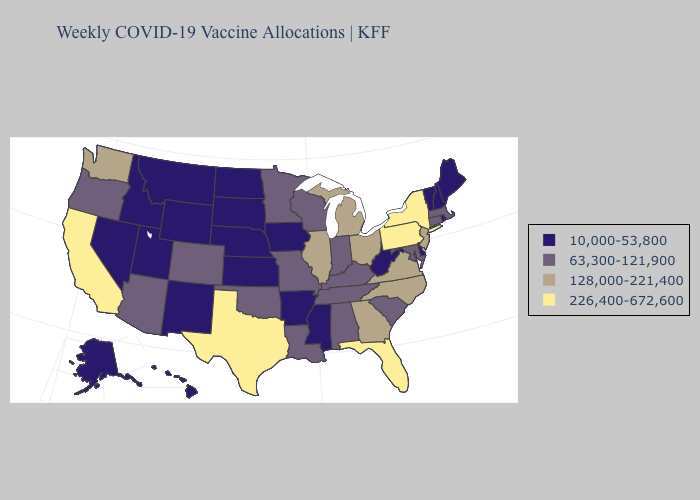Name the states that have a value in the range 63,300-121,900?
Concise answer only. Alabama, Arizona, Colorado, Connecticut, Indiana, Kentucky, Louisiana, Maryland, Massachusetts, Minnesota, Missouri, Oklahoma, Oregon, South Carolina, Tennessee, Wisconsin. Does Utah have the lowest value in the USA?
Be succinct. Yes. Among the states that border Indiana , does Illinois have the lowest value?
Keep it brief. No. What is the lowest value in the West?
Short answer required. 10,000-53,800. What is the highest value in the South ?
Keep it brief. 226,400-672,600. Name the states that have a value in the range 10,000-53,800?
Keep it brief. Alaska, Arkansas, Delaware, Hawaii, Idaho, Iowa, Kansas, Maine, Mississippi, Montana, Nebraska, Nevada, New Hampshire, New Mexico, North Dakota, Rhode Island, South Dakota, Utah, Vermont, West Virginia, Wyoming. Name the states that have a value in the range 63,300-121,900?
Keep it brief. Alabama, Arizona, Colorado, Connecticut, Indiana, Kentucky, Louisiana, Maryland, Massachusetts, Minnesota, Missouri, Oklahoma, Oregon, South Carolina, Tennessee, Wisconsin. Name the states that have a value in the range 63,300-121,900?
Be succinct. Alabama, Arizona, Colorado, Connecticut, Indiana, Kentucky, Louisiana, Maryland, Massachusetts, Minnesota, Missouri, Oklahoma, Oregon, South Carolina, Tennessee, Wisconsin. Name the states that have a value in the range 128,000-221,400?
Answer briefly. Georgia, Illinois, Michigan, New Jersey, North Carolina, Ohio, Virginia, Washington. Name the states that have a value in the range 63,300-121,900?
Be succinct. Alabama, Arizona, Colorado, Connecticut, Indiana, Kentucky, Louisiana, Maryland, Massachusetts, Minnesota, Missouri, Oklahoma, Oregon, South Carolina, Tennessee, Wisconsin. Does the first symbol in the legend represent the smallest category?
Keep it brief. Yes. Name the states that have a value in the range 63,300-121,900?
Short answer required. Alabama, Arizona, Colorado, Connecticut, Indiana, Kentucky, Louisiana, Maryland, Massachusetts, Minnesota, Missouri, Oklahoma, Oregon, South Carolina, Tennessee, Wisconsin. Name the states that have a value in the range 226,400-672,600?
Keep it brief. California, Florida, New York, Pennsylvania, Texas. What is the value of New Jersey?
Give a very brief answer. 128,000-221,400. Does Florida have the highest value in the USA?
Be succinct. Yes. 